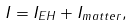Convert formula to latex. <formula><loc_0><loc_0><loc_500><loc_500>I = I _ { E H } + I _ { m a t t e r } ,</formula> 